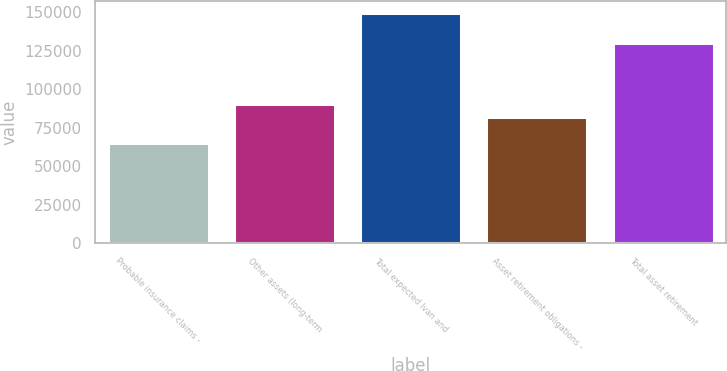<chart> <loc_0><loc_0><loc_500><loc_500><bar_chart><fcel>Probable insurance claims -<fcel>Other assets (long-term<fcel>Total expected Ivan and<fcel>Asset retirement obligations -<fcel>Total asset retirement<nl><fcel>65000<fcel>90449.6<fcel>149832<fcel>81966.4<fcel>130000<nl></chart> 